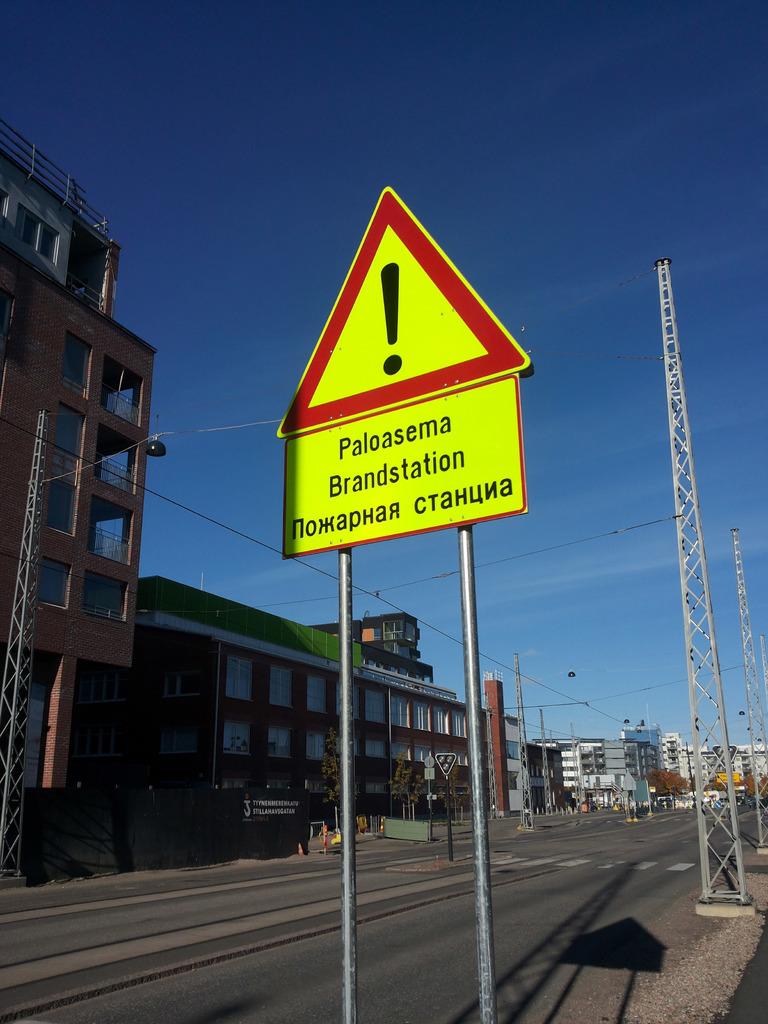Is the road sign in english?
Make the answer very short. No. What station is this sign located at?
Keep it short and to the point. Paloasema. 